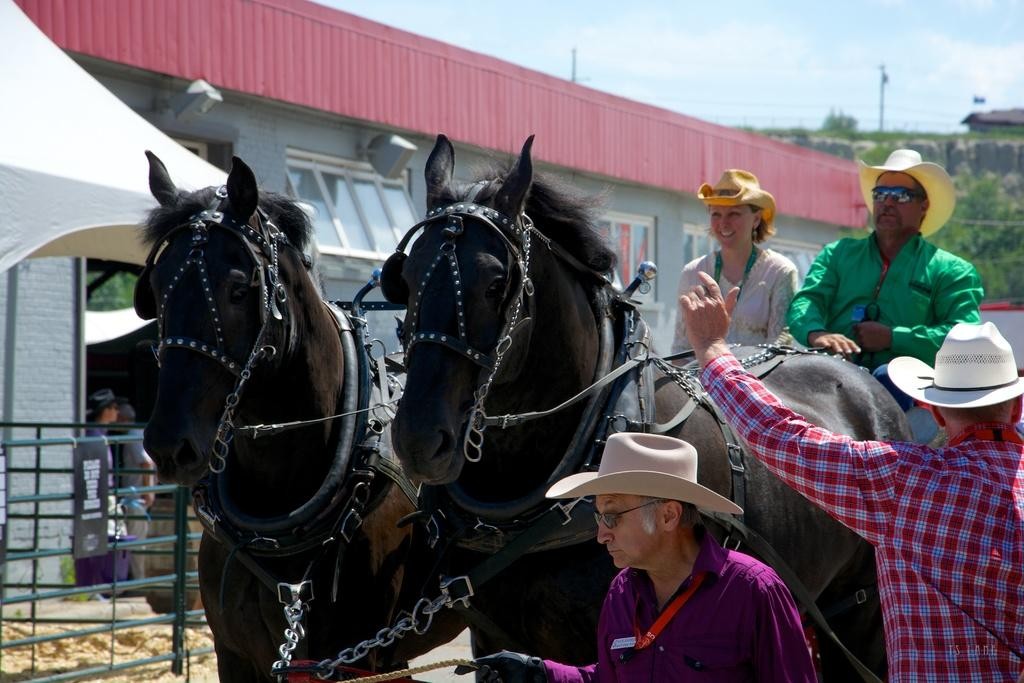What can be seen in the background of the image? There is a sky in the image. What type of structure is present in the image? There is a house in the image. Who or what is present in the image besides the house? There are people and two horses in the image. What type of flowers can be seen in the image? There are no flowers present in the image. What is the reason for the protest in the image? There is no protest depicted in the image. 